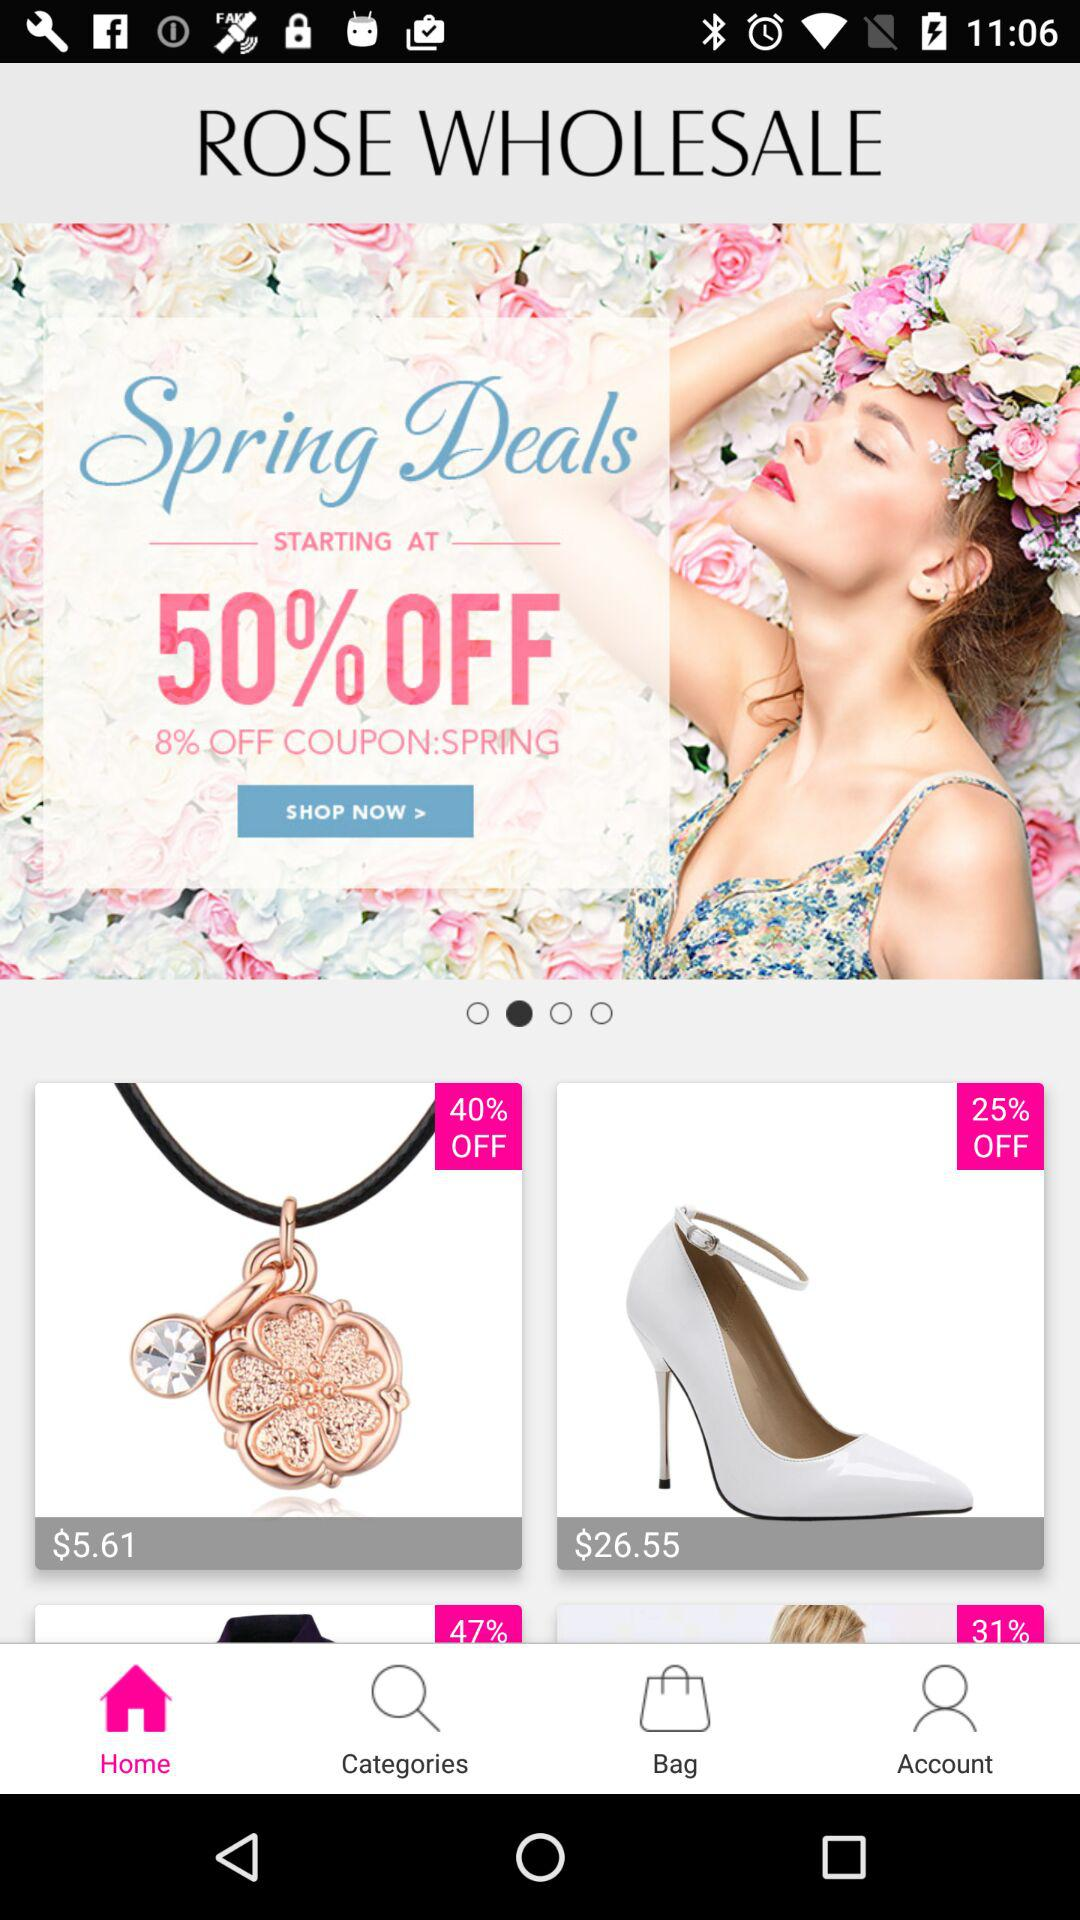How many more items have a 40% discount than a 25% discount?
Answer the question using a single word or phrase. 1 